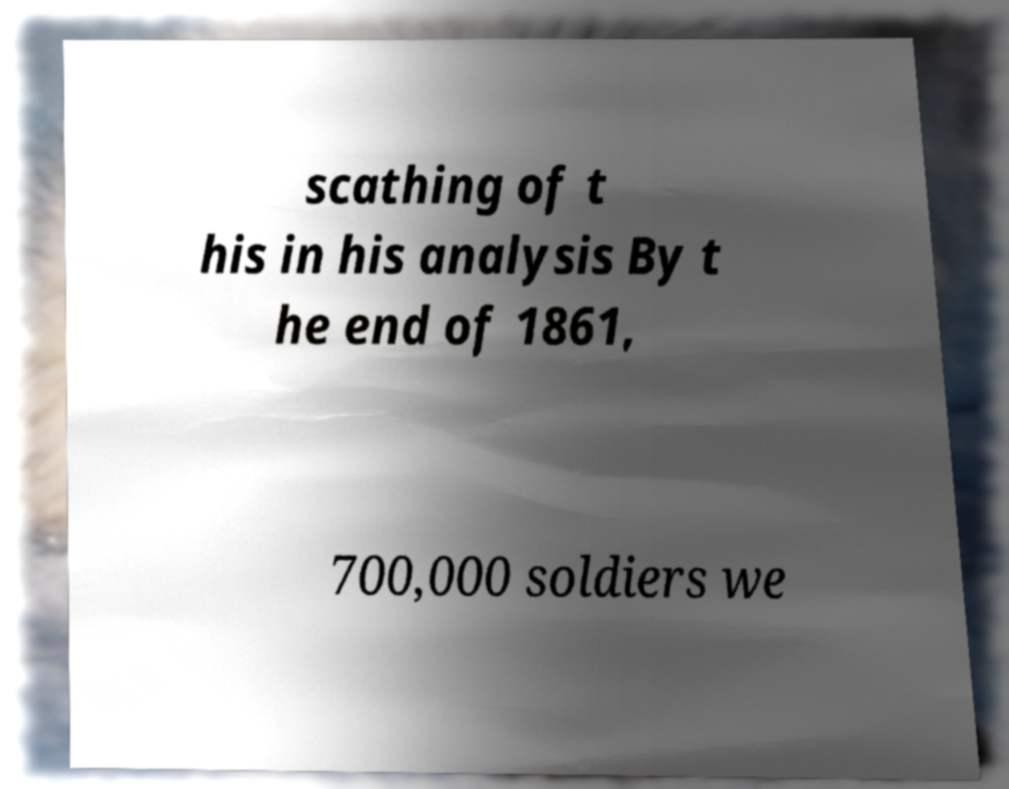Please identify and transcribe the text found in this image. scathing of t his in his analysis By t he end of 1861, 700,000 soldiers we 